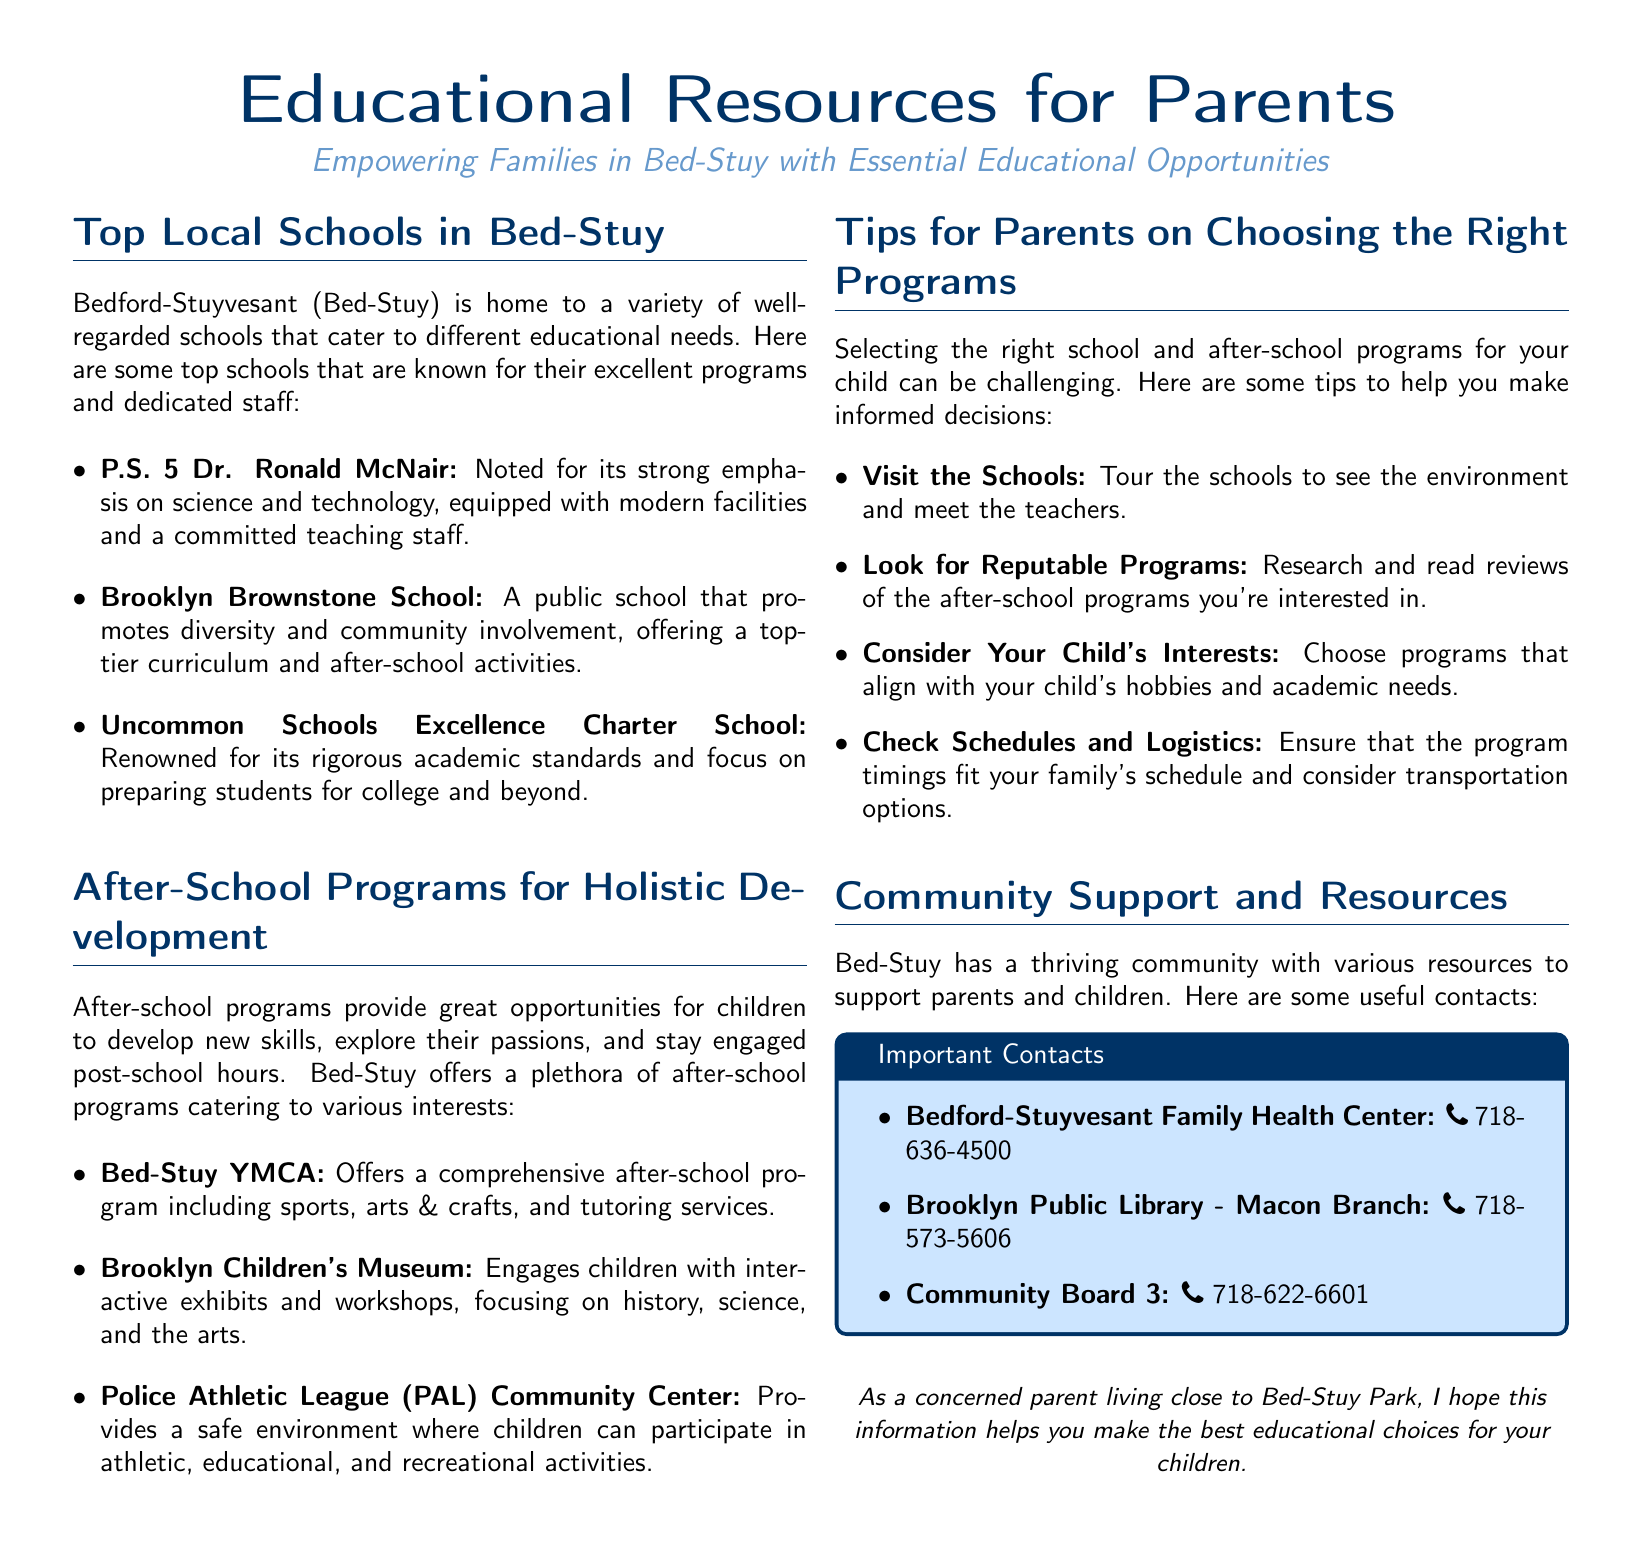What is the name of a school with a strong emphasis on science and technology? The document states that P.S. 5 Dr. Ronald McNair is noted for its strong emphasis on science and technology.
Answer: P.S. 5 Dr. Ronald McNair Which after-school program offers sports, arts & crafts, and tutoring services? The Bed-Stuy YMCA is mentioned as offering a comprehensive after-school program that includes sports, arts & crafts, and tutoring services.
Answer: Bed-Stuy YMCA What is one tip for parents on choosing the right programs? The document lists several tips, one of which is to visit the schools to see the environment and meet the teachers.
Answer: Visit the Schools How many local schools are highlighted in the document? The document lists three top local schools in Bed-Stuy, making a total of three mentioned.
Answer: Three Which community resource provides health services? The Bedford-Stuyvesant Family Health Center is indicated as the community resource that provides health services.
Answer: Bedford-Stuyvesant Family Health Center What type of programs does the Brooklyn Children's Museum focus on? The document states that the Brooklyn Children's Museum focuses on history, science, and the arts through interactive exhibits and workshops.
Answer: History, science, and the arts What kind of facility does the Police Athletic League (PAL) Community Center provide? The document describes the PAL Community Center as providing a safe environment for athletic, educational, and recreational activities.
Answer: Safe environment What color is used for the headlines in the document? The color defined for headlines is RGB(0, 51, 102), which is described as headline color in the document.
Answer: RGB(0, 51, 102) Which library branch is mentioned in the document? The Brooklyn Public Library - Macon Branch is specifically cited in the document as a community resource.
Answer: Brooklyn Public Library - Macon Branch 